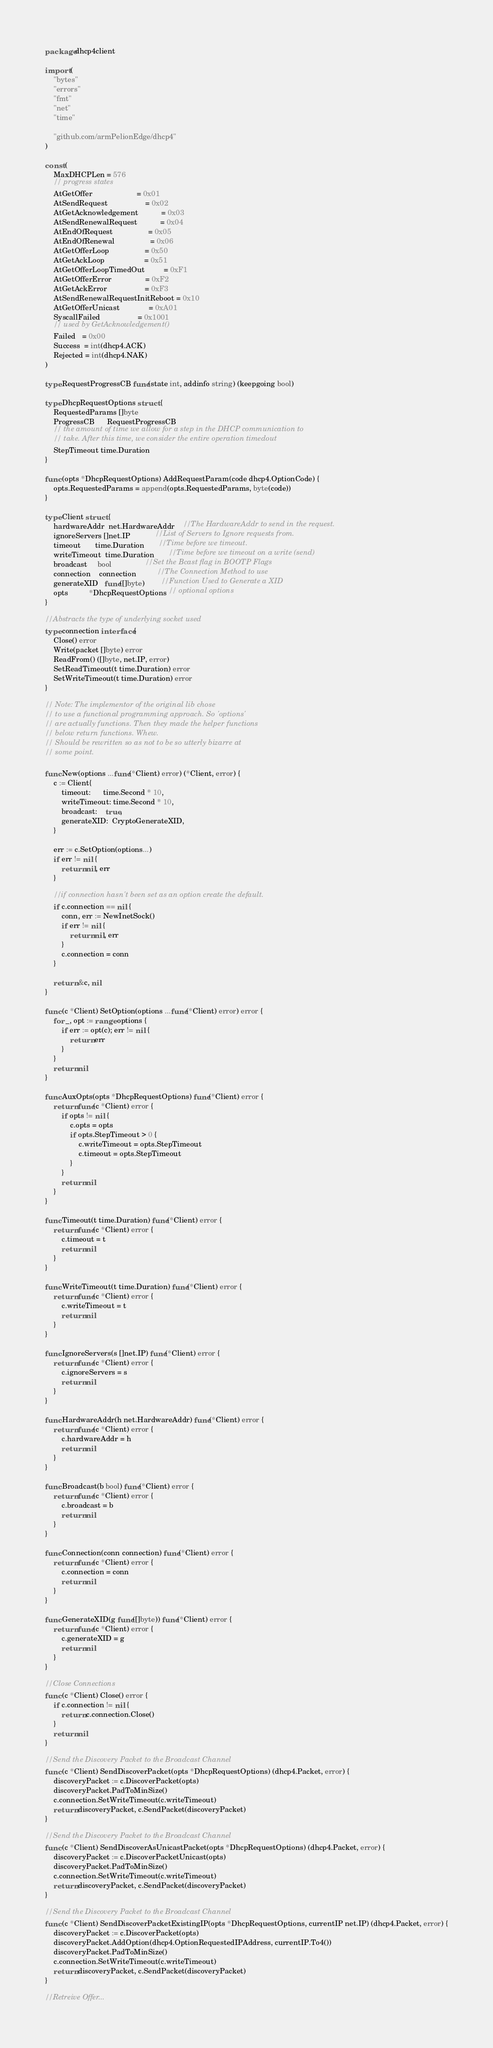Convert code to text. <code><loc_0><loc_0><loc_500><loc_500><_Go_>package dhcp4client

import (
	"bytes"
	"errors"
	"fmt"
	"net"
	"time"

	"github.com/armPelionEdge/dhcp4"
)

const (
	MaxDHCPLen = 576
	// progress states
	AtGetOffer                     = 0x01
	AtSendRequest                  = 0x02
	AtGetAcknowledgement           = 0x03
	AtSendRenewalRequest           = 0x04
	AtEndOfRequest                 = 0x05
	AtEndOfRenewal                 = 0x06
	AtGetOfferLoop                 = 0x50
	AtGetAckLoop                   = 0x51
	AtGetOfferLoopTimedOut         = 0xF1
	AtGetOfferError                = 0xF2
	AtGetAckError                  = 0xF3
	AtSendRenewalRequestInitReboot = 0x10
	AtGetOfferUnicast              = 0xA01
	SyscallFailed                  = 0x1001
	// used by GetAcknowledgement()
	Failed   = 0x00
	Success  = int(dhcp4.ACK)
	Rejected = int(dhcp4.NAK)
)

type RequestProgressCB func(state int, addinfo string) (keepgoing bool)

type DhcpRequestOptions struct {
	RequestedParams []byte
	ProgressCB      RequestProgressCB
	// the amount of time we allow for a step in the DHCP communication to
	// take. After this time, we consider the entire operation timedout
	StepTimeout time.Duration
}

func (opts *DhcpRequestOptions) AddRequestParam(code dhcp4.OptionCode) {
	opts.RequestedParams = append(opts.RequestedParams, byte(code))
}

type Client struct {
	hardwareAddr  net.HardwareAddr    //The HardwareAddr to send in the request.
	ignoreServers []net.IP            //List of Servers to Ignore requests from.
	timeout       time.Duration       //Time before we timeout.
	writeTimeout  time.Duration       //Time before we timeout on a write (send)
	broadcast     bool                //Set the Bcast flag in BOOTP Flags
	connection    connection          //The Connection Method to use
	generateXID   func([]byte)        //Function Used to Generate a XID
	opts          *DhcpRequestOptions // optional options
}

//Abstracts the type of underlying socket used
type connection interface {
	Close() error
	Write(packet []byte) error
	ReadFrom() ([]byte, net.IP, error)
	SetReadTimeout(t time.Duration) error
	SetWriteTimeout(t time.Duration) error
}

// Note: The implementor of the original lib chose
// to use a functional programming approach. So 'options'
// are actually functions. Then they made the helper functions
// below return functions. Whew.
// Should be rewritten so as not to be so utterly bizarre at
// some point.

func New(options ...func(*Client) error) (*Client, error) {
	c := Client{
		timeout:      time.Second * 10,
		writeTimeout: time.Second * 10,
		broadcast:    true,
		generateXID:  CryptoGenerateXID,
	}

	err := c.SetOption(options...)
	if err != nil {
		return nil, err
	}

	//if connection hasn't been set as an option create the default.
	if c.connection == nil {
		conn, err := NewInetSock()
		if err != nil {
			return nil, err
		}
		c.connection = conn
	}

	return &c, nil
}

func (c *Client) SetOption(options ...func(*Client) error) error {
	for _, opt := range options {
		if err := opt(c); err != nil {
			return err
		}
	}
	return nil
}

func AuxOpts(opts *DhcpRequestOptions) func(*Client) error {
	return func(c *Client) error {
		if opts != nil {
			c.opts = opts
			if opts.StepTimeout > 0 {
				c.writeTimeout = opts.StepTimeout
				c.timeout = opts.StepTimeout
			}
		}
		return nil
	}
}

func Timeout(t time.Duration) func(*Client) error {
	return func(c *Client) error {
		c.timeout = t
		return nil
	}
}

func WriteTimeout(t time.Duration) func(*Client) error {
	return func(c *Client) error {
		c.writeTimeout = t
		return nil
	}
}

func IgnoreServers(s []net.IP) func(*Client) error {
	return func(c *Client) error {
		c.ignoreServers = s
		return nil
	}
}

func HardwareAddr(h net.HardwareAddr) func(*Client) error {
	return func(c *Client) error {
		c.hardwareAddr = h
		return nil
	}
}

func Broadcast(b bool) func(*Client) error {
	return func(c *Client) error {
		c.broadcast = b
		return nil
	}
}

func Connection(conn connection) func(*Client) error {
	return func(c *Client) error {
		c.connection = conn
		return nil
	}
}

func GenerateXID(g func([]byte)) func(*Client) error {
	return func(c *Client) error {
		c.generateXID = g
		return nil
	}
}

//Close Connections
func (c *Client) Close() error {
	if c.connection != nil {
		return c.connection.Close()
	}
	return nil
}

//Send the Discovery Packet to the Broadcast Channel
func (c *Client) SendDiscoverPacket(opts *DhcpRequestOptions) (dhcp4.Packet, error) {
	discoveryPacket := c.DiscoverPacket(opts)
	discoveryPacket.PadToMinSize()
	c.connection.SetWriteTimeout(c.writeTimeout)
	return discoveryPacket, c.SendPacket(discoveryPacket)
}

//Send the Discovery Packet to the Broadcast Channel
func (c *Client) SendDiscoverAsUnicastPacket(opts *DhcpRequestOptions) (dhcp4.Packet, error) {
	discoveryPacket := c.DiscoverPacketUnicast(opts)
	discoveryPacket.PadToMinSize()
	c.connection.SetWriteTimeout(c.writeTimeout)
	return discoveryPacket, c.SendPacket(discoveryPacket)
}

//Send the Discovery Packet to the Broadcast Channel
func (c *Client) SendDiscoverPacketExistingIP(opts *DhcpRequestOptions, currentIP net.IP) (dhcp4.Packet, error) {
	discoveryPacket := c.DiscoverPacket(opts)
	discoveryPacket.AddOption(dhcp4.OptionRequestedIPAddress, currentIP.To4())
	discoveryPacket.PadToMinSize()
	c.connection.SetWriteTimeout(c.writeTimeout)
	return discoveryPacket, c.SendPacket(discoveryPacket)
}

//Retreive Offer...</code> 